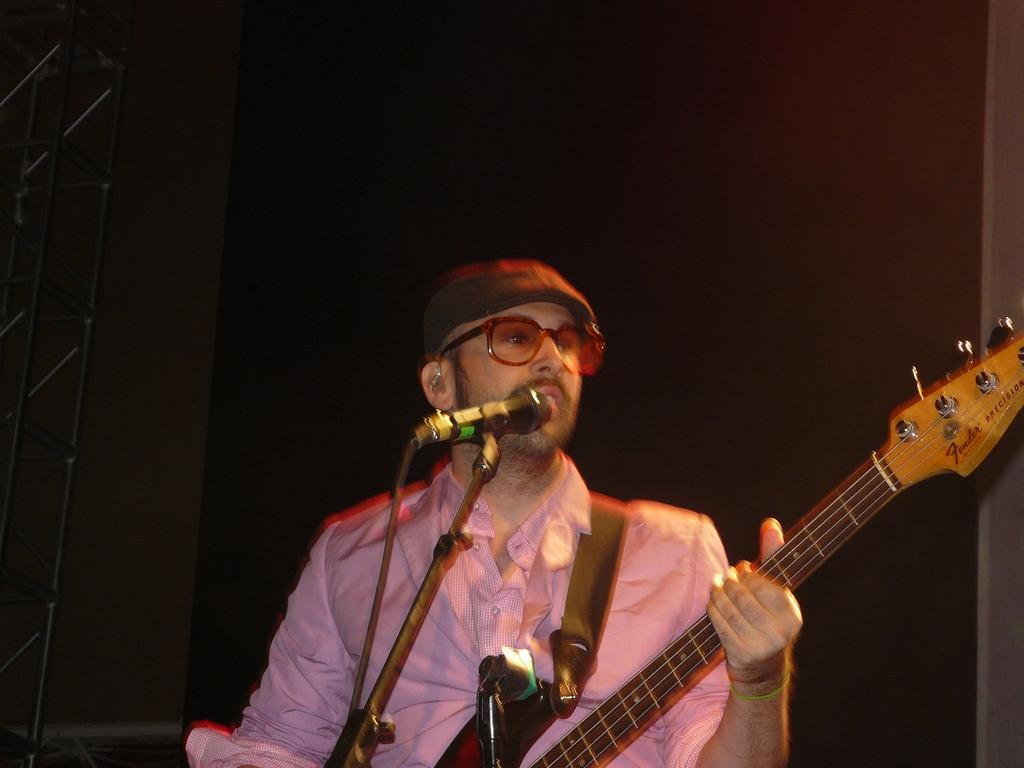In one or two sentences, can you explain what this image depicts? As we can see in the image there is a man holding guitar and in front of him there is a guitar. 